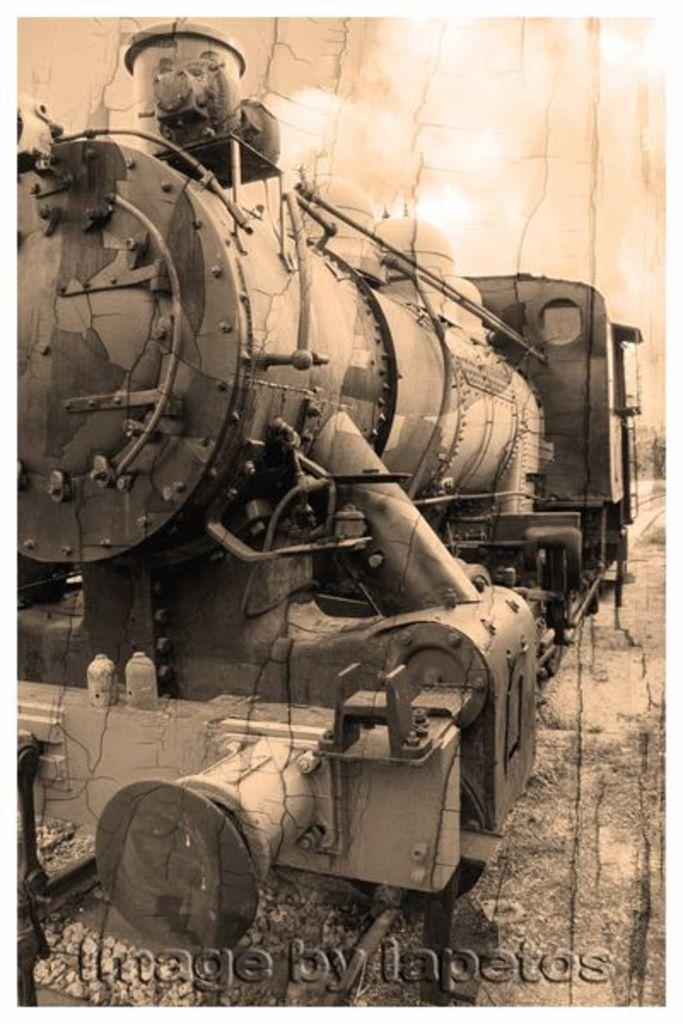What is the main subject of the poster in the image? The main subject of the poster in the image is a train. Where is the train located in the image? The train is on a track in the image. What additional information is provided at the bottom of the poster? There is text at the bottom of the poster. What type of coil is used to transport the train in the image? There is no coil present in the image, and the train is not being transported; it is depicted on a track. What country is the train traveling through in the image? The image is a poster, not a photograph, so it does not depict an actual train traveling through a country. 